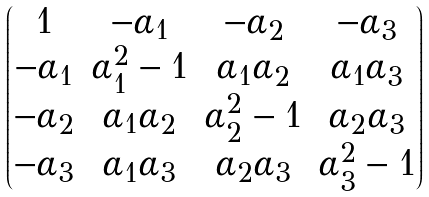<formula> <loc_0><loc_0><loc_500><loc_500>\begin{pmatrix} 1 & - \alpha _ { 1 } & - \alpha _ { 2 } & - \alpha _ { 3 } \\ - \alpha _ { 1 } & \alpha _ { 1 } ^ { 2 } - 1 & \alpha _ { 1 } \alpha _ { 2 } & \alpha _ { 1 } \alpha _ { 3 } \\ - \alpha _ { 2 } & \alpha _ { 1 } \alpha _ { 2 } & \alpha _ { 2 } ^ { 2 } - 1 & \alpha _ { 2 } \alpha _ { 3 } \\ - \alpha _ { 3 } & \alpha _ { 1 } \alpha _ { 3 } & \alpha _ { 2 } \alpha _ { 3 } & \alpha _ { 3 } ^ { 2 } - 1 \end{pmatrix}</formula> 